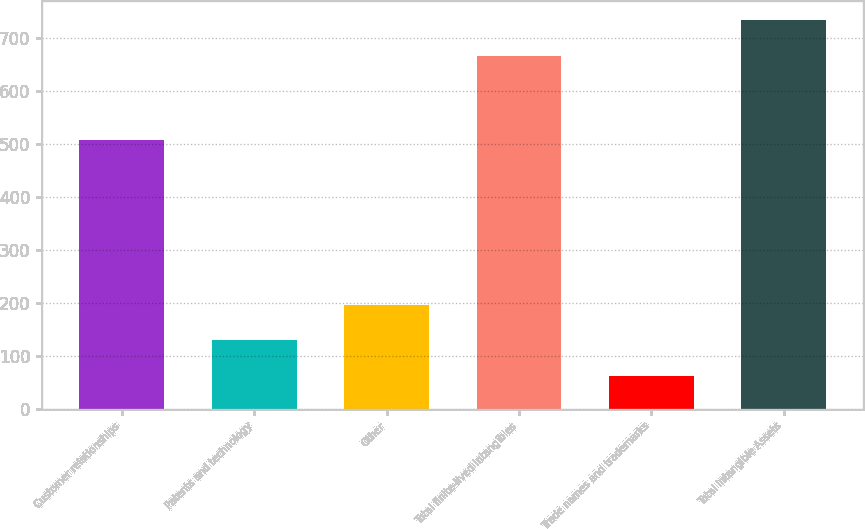Convert chart. <chart><loc_0><loc_0><loc_500><loc_500><bar_chart><fcel>Customer relationships<fcel>Patents and technology<fcel>Other<fcel>Total finite-lived intangibles<fcel>Trade names and trademarks<fcel>Total Intangible Assets<nl><fcel>507.4<fcel>130.01<fcel>196.62<fcel>666.1<fcel>63.4<fcel>732.71<nl></chart> 